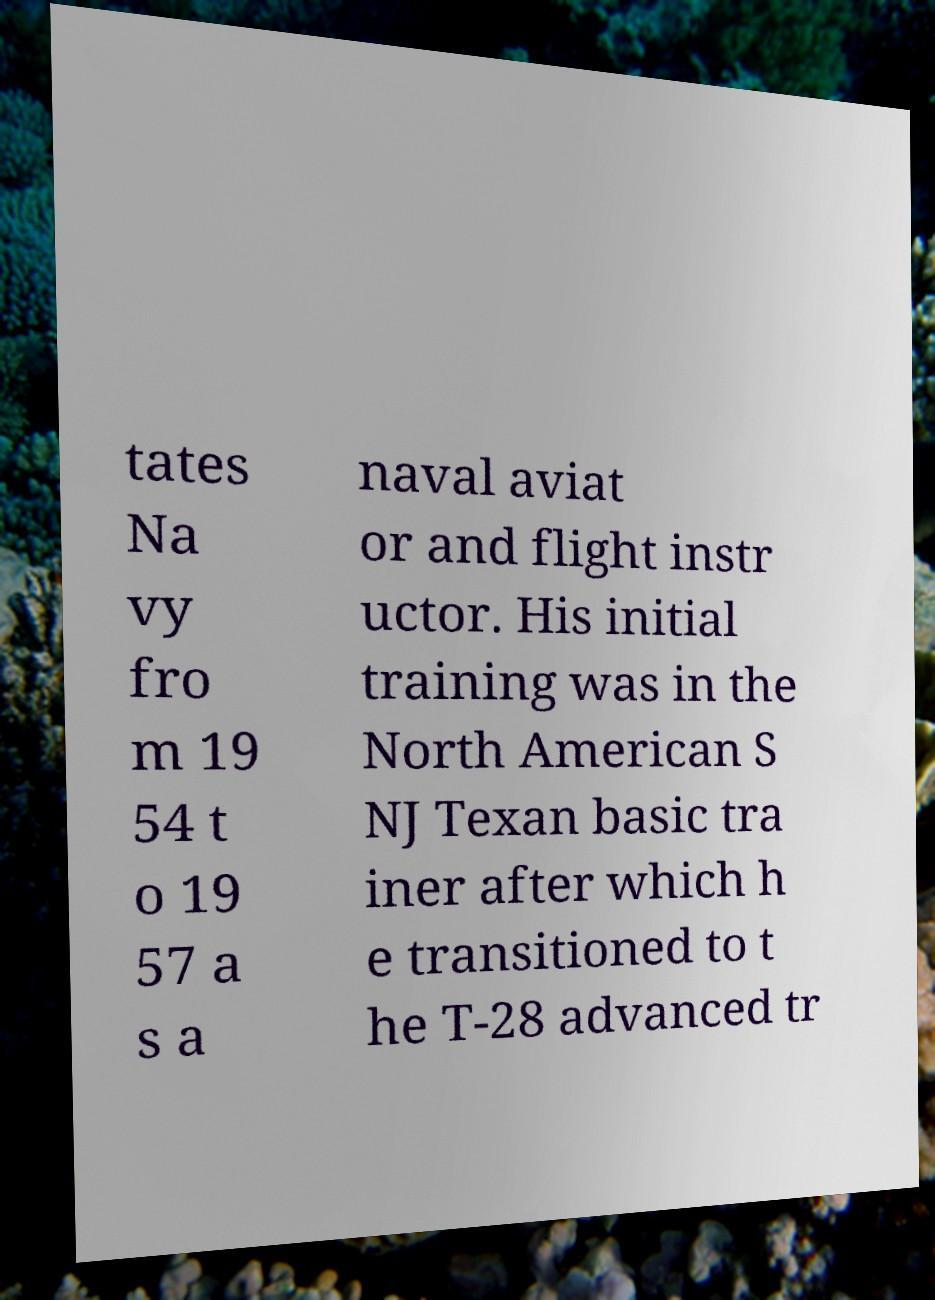Please read and relay the text visible in this image. What does it say? tates Na vy fro m 19 54 t o 19 57 a s a naval aviat or and flight instr uctor. His initial training was in the North American S NJ Texan basic tra iner after which h e transitioned to t he T-28 advanced tr 